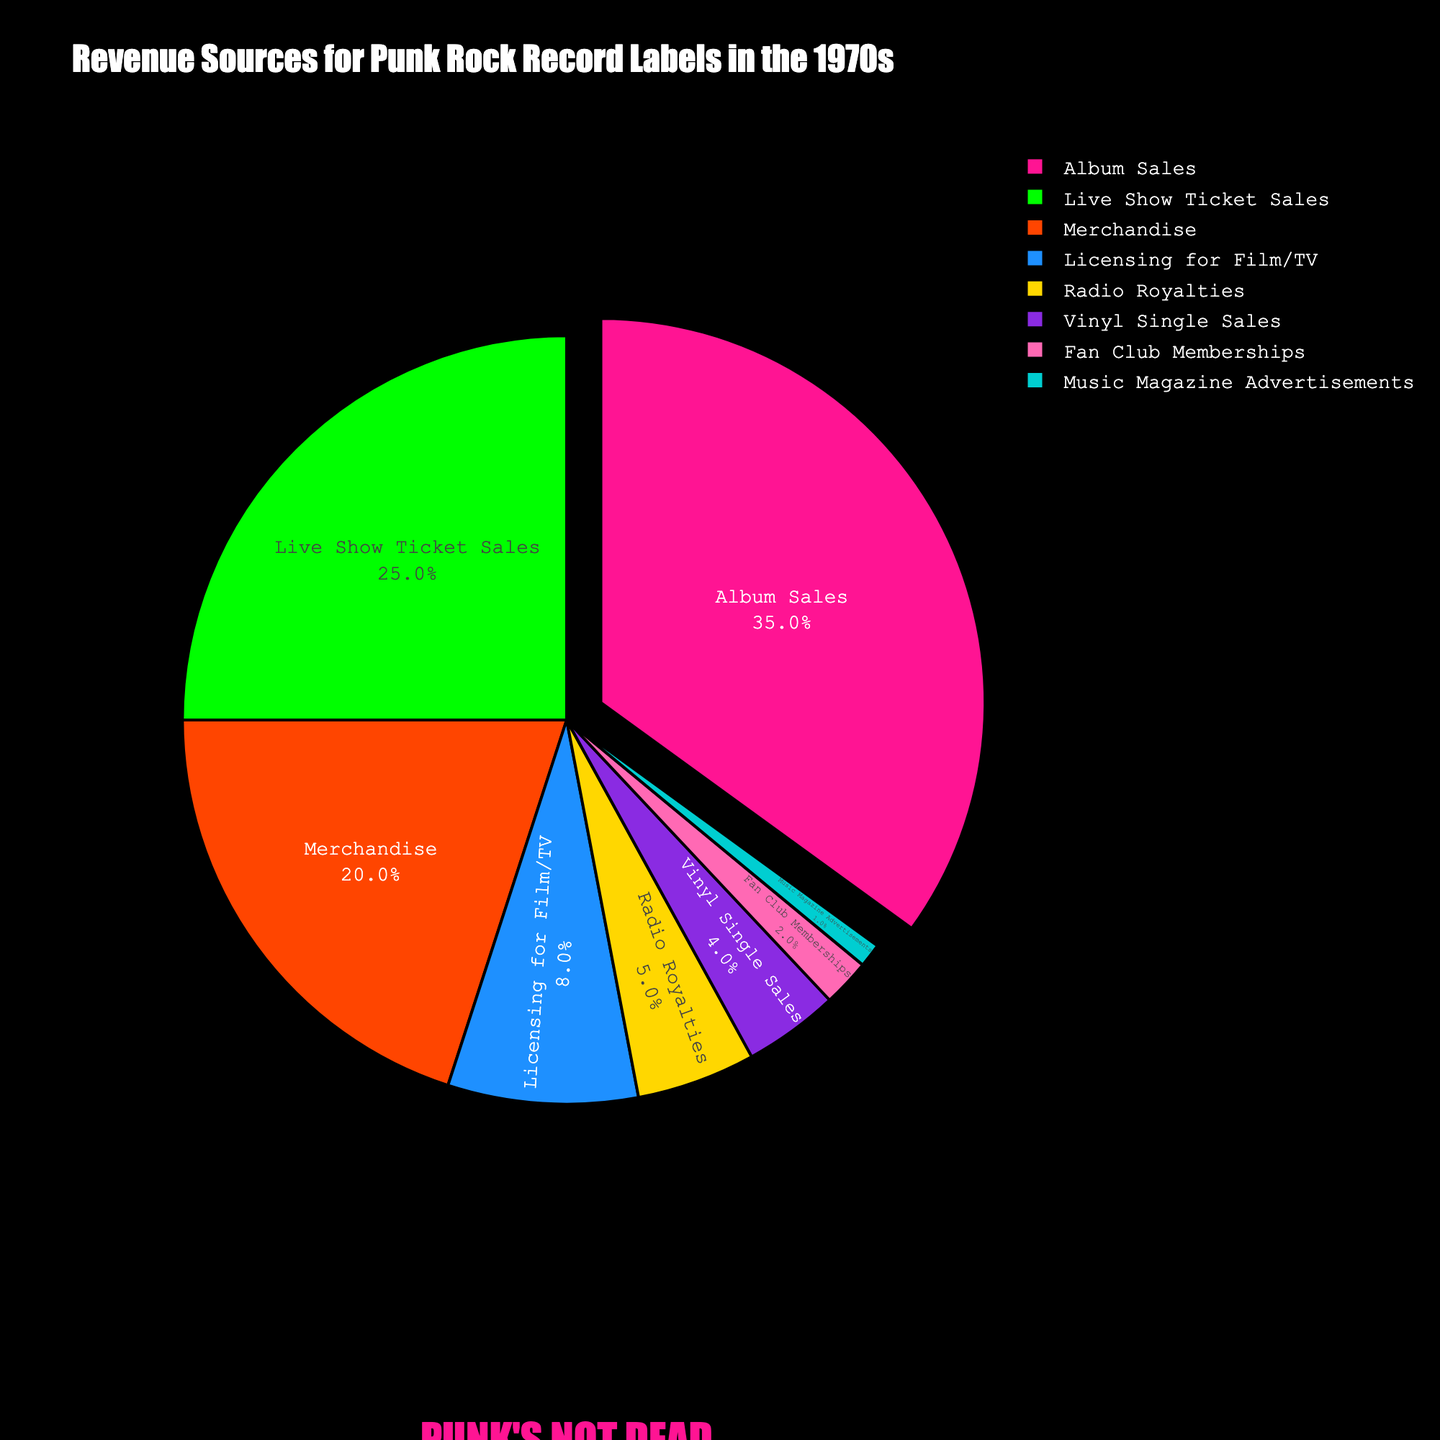What's the largest revenue source for punk rock record labels in the 1970s? The largest segment in the pie chart represents the revenue source that contributes the highest percentage. According to the pie chart, the "Album Sales" segment is the largest, with a percentage of 35%.
Answer: Album Sales Which revenue source has the smallest contribution and what percentage does it have? To find the smallest contribution, look for the smallest segment in the pie chart. The "Music Magazine Advertisements" segment is the smallest, contributing 1% of the revenue.
Answer: Music Magazine Advertisements, 1% What is the combined percentage of revenue coming from Live Show Ticket Sales and Merchandise? Add the percentage of "Live Show Ticket Sales" (25%) to the percentage of "Merchandise" (20%). The combined percentage is 25% + 20% = 45%.
Answer: 45% Which revenue sources are less than 10%? Identify the segments in the pie chart with percentages less than 10%. These are "Licensing for Film/TV" (8%), "Radio Royalties" (5%), "Vinyl Single Sales" (4%), "Fan Club Memberships" (2%), and "Music Magazine Advertisements" (1%).
Answer: Licensing for Film/TV, Radio Royalties, Vinyl Single Sales, Fan Club Memberships, Music Magazine Advertisements How much more revenue is generated from Album Sales compared to Vinyl Single Sales? Subtract the percentage of "Vinyl Single Sales" (4%) from "Album Sales" (35%). The difference is 35% - 4% = 31%.
Answer: 31% If we exclude Album Sales, what is the percentage contribution of Live Show Ticket Sales to the remaining revenue? First, calculate the remaining revenue excluding Album Sales: 100% - 35% = 65%. Then, find the proportion of Live Show Ticket Sales in this remaining revenue: (25% / 65%) * 100 = 38.46%.
Answer: 38.46% Which source has a higher revenue contribution, Licensing for Film/TV or Radio Royalties? Compare the segments of "Licensing for Film/TV" (8%) and "Radio Royalties" (5%). "Licensing for Film/TV" has a higher revenue contribution.
Answer: Licensing for Film/TV What is the percentage difference between merchandise revenue and fan club memberships? Subtract the percentage of "Fan Club Memberships" (2%) from "Merchandise" (20%). The difference is 20% - 2% = 18%.
Answer: 18% Which two revenue sources have a combined total of 30%? Examine the combinations of percentages. "Live Show Ticket Sales" (25%) and "Vinyl Single Sales" (4%) add to 29%, and "Live Show Ticket Sales" (25%) and "Radio Royalties" (5%) add to 30%. Therefore, the correct combination is "Live Show Ticket Sales" and "Radio Royalties."
Answer: Live Show Ticket Sales and Radio Royalties What is the color used to represent Merchandise in the pie chart? According to the described color palette, Merchandise is the third revenue source by percentage (20%) and corresponds to the third color, which is orange.
Answer: Orange 